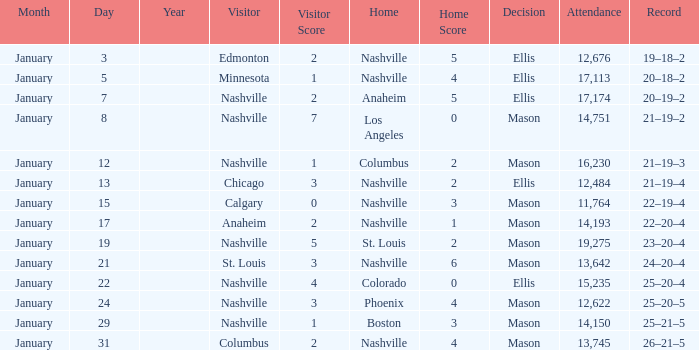On January 15, what was the most in attendance? 11764.0. 